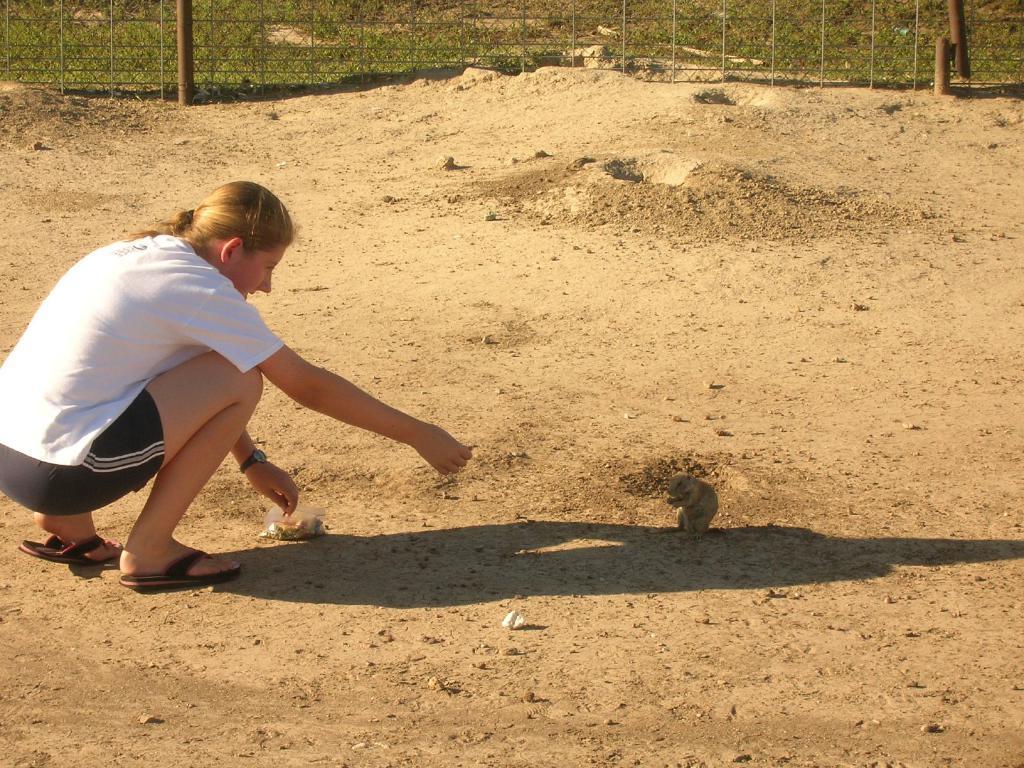How would you summarize this image in a sentence or two? In the center of the image we can see a squirrel. On the left side of the image we can see a lady is sitting on her knees and holding a food item, in-front of her we can see a packet. In the background of the image we can see the sand. At the top of the image we can see the fence and plants. 